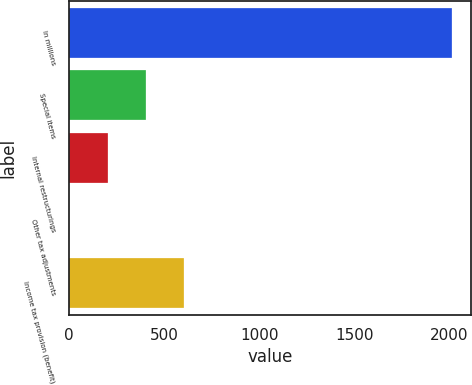<chart> <loc_0><loc_0><loc_500><loc_500><bar_chart><fcel>In millions<fcel>Special items<fcel>Internal restructurings<fcel>Other tax adjustments<fcel>Income tax provision (benefit)<nl><fcel>2014<fcel>403.6<fcel>202.3<fcel>1<fcel>604.9<nl></chart> 